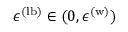<formula> <loc_0><loc_0><loc_500><loc_500>\epsilon ^ { ( l b ) } \in ( 0 , \epsilon ^ { ( w ) } )</formula> 